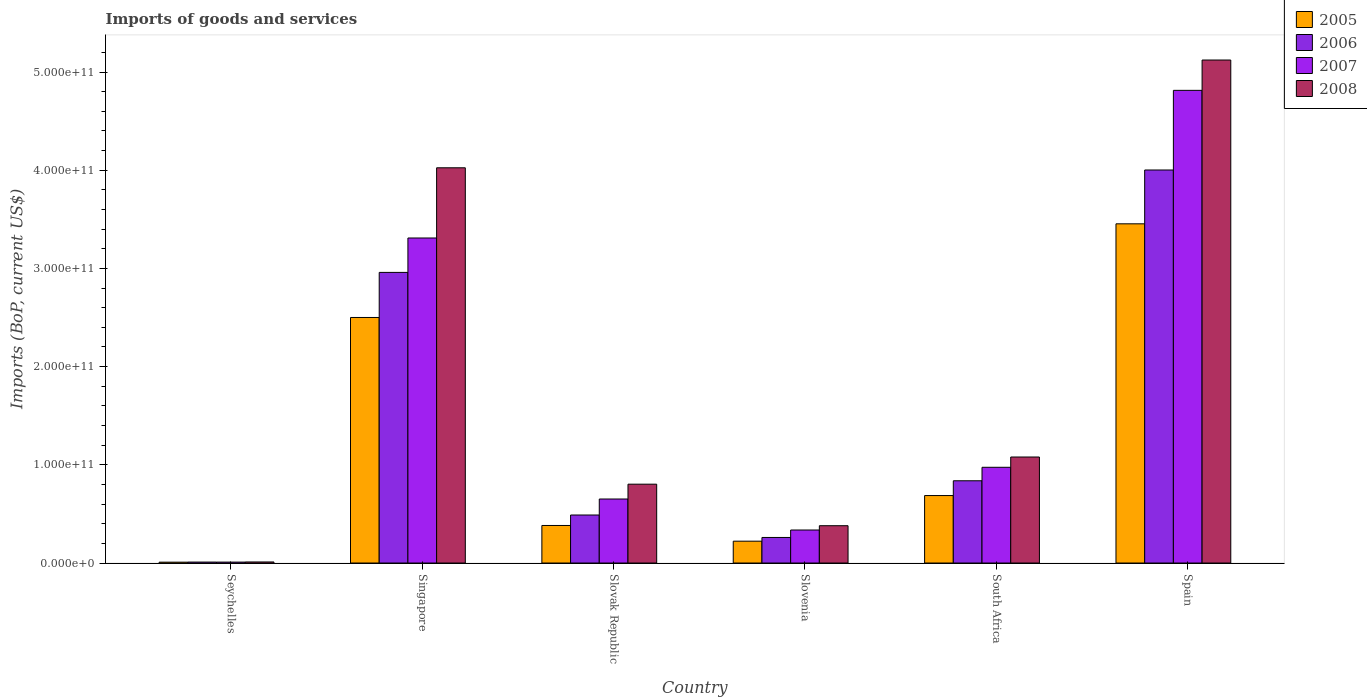How many different coloured bars are there?
Make the answer very short. 4. Are the number of bars per tick equal to the number of legend labels?
Make the answer very short. Yes. Are the number of bars on each tick of the X-axis equal?
Your response must be concise. Yes. How many bars are there on the 4th tick from the right?
Give a very brief answer. 4. What is the label of the 5th group of bars from the left?
Keep it short and to the point. South Africa. In how many cases, is the number of bars for a given country not equal to the number of legend labels?
Keep it short and to the point. 0. What is the amount spent on imports in 2008 in Slovenia?
Ensure brevity in your answer.  3.80e+1. Across all countries, what is the maximum amount spent on imports in 2006?
Ensure brevity in your answer.  4.00e+11. Across all countries, what is the minimum amount spent on imports in 2005?
Your response must be concise. 8.85e+08. In which country was the amount spent on imports in 2005 maximum?
Keep it short and to the point. Spain. In which country was the amount spent on imports in 2005 minimum?
Keep it short and to the point. Seychelles. What is the total amount spent on imports in 2007 in the graph?
Ensure brevity in your answer.  1.01e+12. What is the difference between the amount spent on imports in 2007 in Seychelles and that in Spain?
Provide a short and direct response. -4.80e+11. What is the difference between the amount spent on imports in 2007 in Seychelles and the amount spent on imports in 2005 in Slovak Republic?
Your answer should be compact. -3.73e+1. What is the average amount spent on imports in 2005 per country?
Keep it short and to the point. 1.21e+11. What is the difference between the amount spent on imports of/in 2005 and amount spent on imports of/in 2006 in Spain?
Provide a succinct answer. -5.48e+1. What is the ratio of the amount spent on imports in 2008 in Singapore to that in South Africa?
Make the answer very short. 3.73. Is the amount spent on imports in 2007 in Seychelles less than that in Slovak Republic?
Ensure brevity in your answer.  Yes. What is the difference between the highest and the second highest amount spent on imports in 2008?
Make the answer very short. 1.10e+11. What is the difference between the highest and the lowest amount spent on imports in 2008?
Your answer should be compact. 5.11e+11. In how many countries, is the amount spent on imports in 2006 greater than the average amount spent on imports in 2006 taken over all countries?
Provide a succinct answer. 2. Is the sum of the amount spent on imports in 2006 in Seychelles and Singapore greater than the maximum amount spent on imports in 2005 across all countries?
Offer a terse response. No. How many bars are there?
Provide a succinct answer. 24. Are all the bars in the graph horizontal?
Give a very brief answer. No. What is the difference between two consecutive major ticks on the Y-axis?
Your answer should be compact. 1.00e+11. Does the graph contain grids?
Provide a succinct answer. No. Where does the legend appear in the graph?
Offer a very short reply. Top right. How are the legend labels stacked?
Give a very brief answer. Vertical. What is the title of the graph?
Provide a short and direct response. Imports of goods and services. What is the label or title of the Y-axis?
Make the answer very short. Imports (BoP, current US$). What is the Imports (BoP, current US$) in 2005 in Seychelles?
Your response must be concise. 8.85e+08. What is the Imports (BoP, current US$) in 2006 in Seychelles?
Make the answer very short. 9.85e+08. What is the Imports (BoP, current US$) in 2007 in Seychelles?
Offer a terse response. 9.49e+08. What is the Imports (BoP, current US$) in 2008 in Seychelles?
Make the answer very short. 1.08e+09. What is the Imports (BoP, current US$) of 2005 in Singapore?
Provide a succinct answer. 2.50e+11. What is the Imports (BoP, current US$) of 2006 in Singapore?
Keep it short and to the point. 2.96e+11. What is the Imports (BoP, current US$) in 2007 in Singapore?
Give a very brief answer. 3.31e+11. What is the Imports (BoP, current US$) of 2008 in Singapore?
Your response must be concise. 4.03e+11. What is the Imports (BoP, current US$) in 2005 in Slovak Republic?
Provide a short and direct response. 3.82e+1. What is the Imports (BoP, current US$) in 2006 in Slovak Republic?
Your answer should be compact. 4.89e+1. What is the Imports (BoP, current US$) of 2007 in Slovak Republic?
Keep it short and to the point. 6.52e+1. What is the Imports (BoP, current US$) in 2008 in Slovak Republic?
Provide a short and direct response. 8.03e+1. What is the Imports (BoP, current US$) of 2005 in Slovenia?
Your answer should be very brief. 2.22e+1. What is the Imports (BoP, current US$) of 2006 in Slovenia?
Your answer should be compact. 2.60e+1. What is the Imports (BoP, current US$) in 2007 in Slovenia?
Give a very brief answer. 3.36e+1. What is the Imports (BoP, current US$) in 2008 in Slovenia?
Provide a succinct answer. 3.80e+1. What is the Imports (BoP, current US$) in 2005 in South Africa?
Make the answer very short. 6.87e+1. What is the Imports (BoP, current US$) in 2006 in South Africa?
Make the answer very short. 8.38e+1. What is the Imports (BoP, current US$) of 2007 in South Africa?
Provide a short and direct response. 9.75e+1. What is the Imports (BoP, current US$) of 2008 in South Africa?
Your response must be concise. 1.08e+11. What is the Imports (BoP, current US$) in 2005 in Spain?
Give a very brief answer. 3.45e+11. What is the Imports (BoP, current US$) in 2006 in Spain?
Your answer should be compact. 4.00e+11. What is the Imports (BoP, current US$) in 2007 in Spain?
Your answer should be compact. 4.81e+11. What is the Imports (BoP, current US$) of 2008 in Spain?
Provide a succinct answer. 5.12e+11. Across all countries, what is the maximum Imports (BoP, current US$) in 2005?
Offer a terse response. 3.45e+11. Across all countries, what is the maximum Imports (BoP, current US$) of 2006?
Ensure brevity in your answer.  4.00e+11. Across all countries, what is the maximum Imports (BoP, current US$) in 2007?
Keep it short and to the point. 4.81e+11. Across all countries, what is the maximum Imports (BoP, current US$) in 2008?
Provide a succinct answer. 5.12e+11. Across all countries, what is the minimum Imports (BoP, current US$) in 2005?
Offer a terse response. 8.85e+08. Across all countries, what is the minimum Imports (BoP, current US$) in 2006?
Provide a short and direct response. 9.85e+08. Across all countries, what is the minimum Imports (BoP, current US$) in 2007?
Your answer should be compact. 9.49e+08. Across all countries, what is the minimum Imports (BoP, current US$) of 2008?
Keep it short and to the point. 1.08e+09. What is the total Imports (BoP, current US$) in 2005 in the graph?
Offer a very short reply. 7.26e+11. What is the total Imports (BoP, current US$) in 2006 in the graph?
Your response must be concise. 8.56e+11. What is the total Imports (BoP, current US$) of 2007 in the graph?
Give a very brief answer. 1.01e+12. What is the total Imports (BoP, current US$) of 2008 in the graph?
Offer a terse response. 1.14e+12. What is the difference between the Imports (BoP, current US$) in 2005 in Seychelles and that in Singapore?
Offer a very short reply. -2.49e+11. What is the difference between the Imports (BoP, current US$) of 2006 in Seychelles and that in Singapore?
Provide a succinct answer. -2.95e+11. What is the difference between the Imports (BoP, current US$) of 2007 in Seychelles and that in Singapore?
Provide a short and direct response. -3.30e+11. What is the difference between the Imports (BoP, current US$) in 2008 in Seychelles and that in Singapore?
Keep it short and to the point. -4.01e+11. What is the difference between the Imports (BoP, current US$) in 2005 in Seychelles and that in Slovak Republic?
Keep it short and to the point. -3.74e+1. What is the difference between the Imports (BoP, current US$) of 2006 in Seychelles and that in Slovak Republic?
Ensure brevity in your answer.  -4.79e+1. What is the difference between the Imports (BoP, current US$) in 2007 in Seychelles and that in Slovak Republic?
Provide a succinct answer. -6.43e+1. What is the difference between the Imports (BoP, current US$) in 2008 in Seychelles and that in Slovak Republic?
Make the answer very short. -7.92e+1. What is the difference between the Imports (BoP, current US$) in 2005 in Seychelles and that in Slovenia?
Keep it short and to the point. -2.14e+1. What is the difference between the Imports (BoP, current US$) in 2006 in Seychelles and that in Slovenia?
Keep it short and to the point. -2.51e+1. What is the difference between the Imports (BoP, current US$) of 2007 in Seychelles and that in Slovenia?
Your answer should be compact. -3.27e+1. What is the difference between the Imports (BoP, current US$) of 2008 in Seychelles and that in Slovenia?
Keep it short and to the point. -3.69e+1. What is the difference between the Imports (BoP, current US$) in 2005 in Seychelles and that in South Africa?
Your answer should be very brief. -6.78e+1. What is the difference between the Imports (BoP, current US$) in 2006 in Seychelles and that in South Africa?
Your answer should be very brief. -8.28e+1. What is the difference between the Imports (BoP, current US$) in 2007 in Seychelles and that in South Africa?
Offer a terse response. -9.66e+1. What is the difference between the Imports (BoP, current US$) of 2008 in Seychelles and that in South Africa?
Offer a terse response. -1.07e+11. What is the difference between the Imports (BoP, current US$) of 2005 in Seychelles and that in Spain?
Offer a terse response. -3.45e+11. What is the difference between the Imports (BoP, current US$) in 2006 in Seychelles and that in Spain?
Your answer should be compact. -3.99e+11. What is the difference between the Imports (BoP, current US$) in 2007 in Seychelles and that in Spain?
Your answer should be very brief. -4.80e+11. What is the difference between the Imports (BoP, current US$) in 2008 in Seychelles and that in Spain?
Offer a terse response. -5.11e+11. What is the difference between the Imports (BoP, current US$) of 2005 in Singapore and that in Slovak Republic?
Provide a succinct answer. 2.12e+11. What is the difference between the Imports (BoP, current US$) of 2006 in Singapore and that in Slovak Republic?
Your answer should be compact. 2.47e+11. What is the difference between the Imports (BoP, current US$) of 2007 in Singapore and that in Slovak Republic?
Your answer should be very brief. 2.66e+11. What is the difference between the Imports (BoP, current US$) of 2008 in Singapore and that in Slovak Republic?
Your answer should be very brief. 3.22e+11. What is the difference between the Imports (BoP, current US$) of 2005 in Singapore and that in Slovenia?
Offer a very short reply. 2.28e+11. What is the difference between the Imports (BoP, current US$) in 2006 in Singapore and that in Slovenia?
Your response must be concise. 2.70e+11. What is the difference between the Imports (BoP, current US$) in 2007 in Singapore and that in Slovenia?
Provide a succinct answer. 2.97e+11. What is the difference between the Imports (BoP, current US$) in 2008 in Singapore and that in Slovenia?
Keep it short and to the point. 3.64e+11. What is the difference between the Imports (BoP, current US$) of 2005 in Singapore and that in South Africa?
Provide a short and direct response. 1.81e+11. What is the difference between the Imports (BoP, current US$) in 2006 in Singapore and that in South Africa?
Provide a short and direct response. 2.12e+11. What is the difference between the Imports (BoP, current US$) in 2007 in Singapore and that in South Africa?
Make the answer very short. 2.34e+11. What is the difference between the Imports (BoP, current US$) of 2008 in Singapore and that in South Africa?
Make the answer very short. 2.95e+11. What is the difference between the Imports (BoP, current US$) in 2005 in Singapore and that in Spain?
Your answer should be very brief. -9.54e+1. What is the difference between the Imports (BoP, current US$) of 2006 in Singapore and that in Spain?
Provide a short and direct response. -1.04e+11. What is the difference between the Imports (BoP, current US$) in 2007 in Singapore and that in Spain?
Give a very brief answer. -1.50e+11. What is the difference between the Imports (BoP, current US$) in 2008 in Singapore and that in Spain?
Your answer should be compact. -1.10e+11. What is the difference between the Imports (BoP, current US$) of 2005 in Slovak Republic and that in Slovenia?
Provide a succinct answer. 1.60e+1. What is the difference between the Imports (BoP, current US$) in 2006 in Slovak Republic and that in Slovenia?
Keep it short and to the point. 2.29e+1. What is the difference between the Imports (BoP, current US$) of 2007 in Slovak Republic and that in Slovenia?
Your answer should be compact. 3.16e+1. What is the difference between the Imports (BoP, current US$) of 2008 in Slovak Republic and that in Slovenia?
Your response must be concise. 4.23e+1. What is the difference between the Imports (BoP, current US$) of 2005 in Slovak Republic and that in South Africa?
Provide a succinct answer. -3.05e+1. What is the difference between the Imports (BoP, current US$) of 2006 in Slovak Republic and that in South Africa?
Offer a very short reply. -3.49e+1. What is the difference between the Imports (BoP, current US$) in 2007 in Slovak Republic and that in South Africa?
Provide a short and direct response. -3.23e+1. What is the difference between the Imports (BoP, current US$) of 2008 in Slovak Republic and that in South Africa?
Give a very brief answer. -2.77e+1. What is the difference between the Imports (BoP, current US$) of 2005 in Slovak Republic and that in Spain?
Keep it short and to the point. -3.07e+11. What is the difference between the Imports (BoP, current US$) in 2006 in Slovak Republic and that in Spain?
Offer a terse response. -3.51e+11. What is the difference between the Imports (BoP, current US$) of 2007 in Slovak Republic and that in Spain?
Give a very brief answer. -4.16e+11. What is the difference between the Imports (BoP, current US$) of 2008 in Slovak Republic and that in Spain?
Give a very brief answer. -4.32e+11. What is the difference between the Imports (BoP, current US$) in 2005 in Slovenia and that in South Africa?
Ensure brevity in your answer.  -4.65e+1. What is the difference between the Imports (BoP, current US$) in 2006 in Slovenia and that in South Africa?
Ensure brevity in your answer.  -5.77e+1. What is the difference between the Imports (BoP, current US$) of 2007 in Slovenia and that in South Africa?
Ensure brevity in your answer.  -6.39e+1. What is the difference between the Imports (BoP, current US$) of 2008 in Slovenia and that in South Africa?
Ensure brevity in your answer.  -7.00e+1. What is the difference between the Imports (BoP, current US$) of 2005 in Slovenia and that in Spain?
Give a very brief answer. -3.23e+11. What is the difference between the Imports (BoP, current US$) in 2006 in Slovenia and that in Spain?
Offer a very short reply. -3.74e+11. What is the difference between the Imports (BoP, current US$) in 2007 in Slovenia and that in Spain?
Ensure brevity in your answer.  -4.48e+11. What is the difference between the Imports (BoP, current US$) in 2008 in Slovenia and that in Spain?
Keep it short and to the point. -4.74e+11. What is the difference between the Imports (BoP, current US$) of 2005 in South Africa and that in Spain?
Ensure brevity in your answer.  -2.77e+11. What is the difference between the Imports (BoP, current US$) of 2006 in South Africa and that in Spain?
Your answer should be compact. -3.16e+11. What is the difference between the Imports (BoP, current US$) in 2007 in South Africa and that in Spain?
Keep it short and to the point. -3.84e+11. What is the difference between the Imports (BoP, current US$) of 2008 in South Africa and that in Spain?
Keep it short and to the point. -4.04e+11. What is the difference between the Imports (BoP, current US$) in 2005 in Seychelles and the Imports (BoP, current US$) in 2006 in Singapore?
Provide a short and direct response. -2.95e+11. What is the difference between the Imports (BoP, current US$) of 2005 in Seychelles and the Imports (BoP, current US$) of 2007 in Singapore?
Offer a very short reply. -3.30e+11. What is the difference between the Imports (BoP, current US$) in 2005 in Seychelles and the Imports (BoP, current US$) in 2008 in Singapore?
Provide a succinct answer. -4.02e+11. What is the difference between the Imports (BoP, current US$) in 2006 in Seychelles and the Imports (BoP, current US$) in 2007 in Singapore?
Ensure brevity in your answer.  -3.30e+11. What is the difference between the Imports (BoP, current US$) in 2006 in Seychelles and the Imports (BoP, current US$) in 2008 in Singapore?
Your response must be concise. -4.02e+11. What is the difference between the Imports (BoP, current US$) of 2007 in Seychelles and the Imports (BoP, current US$) of 2008 in Singapore?
Give a very brief answer. -4.02e+11. What is the difference between the Imports (BoP, current US$) in 2005 in Seychelles and the Imports (BoP, current US$) in 2006 in Slovak Republic?
Ensure brevity in your answer.  -4.80e+1. What is the difference between the Imports (BoP, current US$) of 2005 in Seychelles and the Imports (BoP, current US$) of 2007 in Slovak Republic?
Offer a terse response. -6.43e+1. What is the difference between the Imports (BoP, current US$) in 2005 in Seychelles and the Imports (BoP, current US$) in 2008 in Slovak Republic?
Ensure brevity in your answer.  -7.94e+1. What is the difference between the Imports (BoP, current US$) of 2006 in Seychelles and the Imports (BoP, current US$) of 2007 in Slovak Republic?
Provide a succinct answer. -6.42e+1. What is the difference between the Imports (BoP, current US$) of 2006 in Seychelles and the Imports (BoP, current US$) of 2008 in Slovak Republic?
Your answer should be very brief. -7.93e+1. What is the difference between the Imports (BoP, current US$) in 2007 in Seychelles and the Imports (BoP, current US$) in 2008 in Slovak Republic?
Your response must be concise. -7.93e+1. What is the difference between the Imports (BoP, current US$) in 2005 in Seychelles and the Imports (BoP, current US$) in 2006 in Slovenia?
Your answer should be compact. -2.52e+1. What is the difference between the Imports (BoP, current US$) in 2005 in Seychelles and the Imports (BoP, current US$) in 2007 in Slovenia?
Offer a terse response. -3.27e+1. What is the difference between the Imports (BoP, current US$) of 2005 in Seychelles and the Imports (BoP, current US$) of 2008 in Slovenia?
Keep it short and to the point. -3.71e+1. What is the difference between the Imports (BoP, current US$) in 2006 in Seychelles and the Imports (BoP, current US$) in 2007 in Slovenia?
Your answer should be compact. -3.26e+1. What is the difference between the Imports (BoP, current US$) of 2006 in Seychelles and the Imports (BoP, current US$) of 2008 in Slovenia?
Your response must be concise. -3.70e+1. What is the difference between the Imports (BoP, current US$) in 2007 in Seychelles and the Imports (BoP, current US$) in 2008 in Slovenia?
Your response must be concise. -3.71e+1. What is the difference between the Imports (BoP, current US$) in 2005 in Seychelles and the Imports (BoP, current US$) in 2006 in South Africa?
Your answer should be compact. -8.29e+1. What is the difference between the Imports (BoP, current US$) of 2005 in Seychelles and the Imports (BoP, current US$) of 2007 in South Africa?
Your answer should be compact. -9.66e+1. What is the difference between the Imports (BoP, current US$) in 2005 in Seychelles and the Imports (BoP, current US$) in 2008 in South Africa?
Provide a short and direct response. -1.07e+11. What is the difference between the Imports (BoP, current US$) of 2006 in Seychelles and the Imports (BoP, current US$) of 2007 in South Africa?
Offer a very short reply. -9.65e+1. What is the difference between the Imports (BoP, current US$) of 2006 in Seychelles and the Imports (BoP, current US$) of 2008 in South Africa?
Provide a succinct answer. -1.07e+11. What is the difference between the Imports (BoP, current US$) in 2007 in Seychelles and the Imports (BoP, current US$) in 2008 in South Africa?
Offer a very short reply. -1.07e+11. What is the difference between the Imports (BoP, current US$) in 2005 in Seychelles and the Imports (BoP, current US$) in 2006 in Spain?
Your answer should be compact. -3.99e+11. What is the difference between the Imports (BoP, current US$) of 2005 in Seychelles and the Imports (BoP, current US$) of 2007 in Spain?
Offer a terse response. -4.80e+11. What is the difference between the Imports (BoP, current US$) in 2005 in Seychelles and the Imports (BoP, current US$) in 2008 in Spain?
Your answer should be very brief. -5.11e+11. What is the difference between the Imports (BoP, current US$) of 2006 in Seychelles and the Imports (BoP, current US$) of 2007 in Spain?
Provide a short and direct response. -4.80e+11. What is the difference between the Imports (BoP, current US$) of 2006 in Seychelles and the Imports (BoP, current US$) of 2008 in Spain?
Ensure brevity in your answer.  -5.11e+11. What is the difference between the Imports (BoP, current US$) of 2007 in Seychelles and the Imports (BoP, current US$) of 2008 in Spain?
Your answer should be very brief. -5.11e+11. What is the difference between the Imports (BoP, current US$) of 2005 in Singapore and the Imports (BoP, current US$) of 2006 in Slovak Republic?
Keep it short and to the point. 2.01e+11. What is the difference between the Imports (BoP, current US$) of 2005 in Singapore and the Imports (BoP, current US$) of 2007 in Slovak Republic?
Offer a very short reply. 1.85e+11. What is the difference between the Imports (BoP, current US$) of 2005 in Singapore and the Imports (BoP, current US$) of 2008 in Slovak Republic?
Your answer should be compact. 1.70e+11. What is the difference between the Imports (BoP, current US$) in 2006 in Singapore and the Imports (BoP, current US$) in 2007 in Slovak Republic?
Keep it short and to the point. 2.31e+11. What is the difference between the Imports (BoP, current US$) in 2006 in Singapore and the Imports (BoP, current US$) in 2008 in Slovak Republic?
Offer a terse response. 2.16e+11. What is the difference between the Imports (BoP, current US$) in 2007 in Singapore and the Imports (BoP, current US$) in 2008 in Slovak Republic?
Keep it short and to the point. 2.51e+11. What is the difference between the Imports (BoP, current US$) in 2005 in Singapore and the Imports (BoP, current US$) in 2006 in Slovenia?
Offer a terse response. 2.24e+11. What is the difference between the Imports (BoP, current US$) of 2005 in Singapore and the Imports (BoP, current US$) of 2007 in Slovenia?
Provide a succinct answer. 2.16e+11. What is the difference between the Imports (BoP, current US$) in 2005 in Singapore and the Imports (BoP, current US$) in 2008 in Slovenia?
Provide a succinct answer. 2.12e+11. What is the difference between the Imports (BoP, current US$) in 2006 in Singapore and the Imports (BoP, current US$) in 2007 in Slovenia?
Ensure brevity in your answer.  2.62e+11. What is the difference between the Imports (BoP, current US$) of 2006 in Singapore and the Imports (BoP, current US$) of 2008 in Slovenia?
Provide a succinct answer. 2.58e+11. What is the difference between the Imports (BoP, current US$) of 2007 in Singapore and the Imports (BoP, current US$) of 2008 in Slovenia?
Provide a short and direct response. 2.93e+11. What is the difference between the Imports (BoP, current US$) in 2005 in Singapore and the Imports (BoP, current US$) in 2006 in South Africa?
Provide a succinct answer. 1.66e+11. What is the difference between the Imports (BoP, current US$) of 2005 in Singapore and the Imports (BoP, current US$) of 2007 in South Africa?
Provide a short and direct response. 1.53e+11. What is the difference between the Imports (BoP, current US$) of 2005 in Singapore and the Imports (BoP, current US$) of 2008 in South Africa?
Give a very brief answer. 1.42e+11. What is the difference between the Imports (BoP, current US$) of 2006 in Singapore and the Imports (BoP, current US$) of 2007 in South Africa?
Make the answer very short. 1.98e+11. What is the difference between the Imports (BoP, current US$) of 2006 in Singapore and the Imports (BoP, current US$) of 2008 in South Africa?
Ensure brevity in your answer.  1.88e+11. What is the difference between the Imports (BoP, current US$) of 2007 in Singapore and the Imports (BoP, current US$) of 2008 in South Africa?
Keep it short and to the point. 2.23e+11. What is the difference between the Imports (BoP, current US$) of 2005 in Singapore and the Imports (BoP, current US$) of 2006 in Spain?
Ensure brevity in your answer.  -1.50e+11. What is the difference between the Imports (BoP, current US$) of 2005 in Singapore and the Imports (BoP, current US$) of 2007 in Spain?
Keep it short and to the point. -2.31e+11. What is the difference between the Imports (BoP, current US$) in 2005 in Singapore and the Imports (BoP, current US$) in 2008 in Spain?
Give a very brief answer. -2.62e+11. What is the difference between the Imports (BoP, current US$) of 2006 in Singapore and the Imports (BoP, current US$) of 2007 in Spain?
Provide a short and direct response. -1.85e+11. What is the difference between the Imports (BoP, current US$) in 2006 in Singapore and the Imports (BoP, current US$) in 2008 in Spain?
Make the answer very short. -2.16e+11. What is the difference between the Imports (BoP, current US$) of 2007 in Singapore and the Imports (BoP, current US$) of 2008 in Spain?
Give a very brief answer. -1.81e+11. What is the difference between the Imports (BoP, current US$) in 2005 in Slovak Republic and the Imports (BoP, current US$) in 2006 in Slovenia?
Offer a terse response. 1.22e+1. What is the difference between the Imports (BoP, current US$) of 2005 in Slovak Republic and the Imports (BoP, current US$) of 2007 in Slovenia?
Your answer should be very brief. 4.62e+09. What is the difference between the Imports (BoP, current US$) of 2005 in Slovak Republic and the Imports (BoP, current US$) of 2008 in Slovenia?
Keep it short and to the point. 2.41e+08. What is the difference between the Imports (BoP, current US$) of 2006 in Slovak Republic and the Imports (BoP, current US$) of 2007 in Slovenia?
Offer a very short reply. 1.53e+1. What is the difference between the Imports (BoP, current US$) of 2006 in Slovak Republic and the Imports (BoP, current US$) of 2008 in Slovenia?
Make the answer very short. 1.09e+1. What is the difference between the Imports (BoP, current US$) of 2007 in Slovak Republic and the Imports (BoP, current US$) of 2008 in Slovenia?
Your answer should be compact. 2.72e+1. What is the difference between the Imports (BoP, current US$) in 2005 in Slovak Republic and the Imports (BoP, current US$) in 2006 in South Africa?
Offer a very short reply. -4.55e+1. What is the difference between the Imports (BoP, current US$) in 2005 in Slovak Republic and the Imports (BoP, current US$) in 2007 in South Africa?
Ensure brevity in your answer.  -5.93e+1. What is the difference between the Imports (BoP, current US$) of 2005 in Slovak Republic and the Imports (BoP, current US$) of 2008 in South Africa?
Provide a succinct answer. -6.97e+1. What is the difference between the Imports (BoP, current US$) in 2006 in Slovak Republic and the Imports (BoP, current US$) in 2007 in South Africa?
Provide a succinct answer. -4.86e+1. What is the difference between the Imports (BoP, current US$) in 2006 in Slovak Republic and the Imports (BoP, current US$) in 2008 in South Africa?
Your response must be concise. -5.91e+1. What is the difference between the Imports (BoP, current US$) of 2007 in Slovak Republic and the Imports (BoP, current US$) of 2008 in South Africa?
Your answer should be compact. -4.28e+1. What is the difference between the Imports (BoP, current US$) in 2005 in Slovak Republic and the Imports (BoP, current US$) in 2006 in Spain?
Offer a terse response. -3.62e+11. What is the difference between the Imports (BoP, current US$) of 2005 in Slovak Republic and the Imports (BoP, current US$) of 2007 in Spain?
Make the answer very short. -4.43e+11. What is the difference between the Imports (BoP, current US$) in 2005 in Slovak Republic and the Imports (BoP, current US$) in 2008 in Spain?
Provide a succinct answer. -4.74e+11. What is the difference between the Imports (BoP, current US$) of 2006 in Slovak Republic and the Imports (BoP, current US$) of 2007 in Spain?
Offer a terse response. -4.32e+11. What is the difference between the Imports (BoP, current US$) in 2006 in Slovak Republic and the Imports (BoP, current US$) in 2008 in Spain?
Offer a terse response. -4.63e+11. What is the difference between the Imports (BoP, current US$) in 2007 in Slovak Republic and the Imports (BoP, current US$) in 2008 in Spain?
Give a very brief answer. -4.47e+11. What is the difference between the Imports (BoP, current US$) in 2005 in Slovenia and the Imports (BoP, current US$) in 2006 in South Africa?
Provide a succinct answer. -6.15e+1. What is the difference between the Imports (BoP, current US$) in 2005 in Slovenia and the Imports (BoP, current US$) in 2007 in South Africa?
Offer a very short reply. -7.53e+1. What is the difference between the Imports (BoP, current US$) in 2005 in Slovenia and the Imports (BoP, current US$) in 2008 in South Africa?
Make the answer very short. -8.57e+1. What is the difference between the Imports (BoP, current US$) of 2006 in Slovenia and the Imports (BoP, current US$) of 2007 in South Africa?
Your answer should be very brief. -7.15e+1. What is the difference between the Imports (BoP, current US$) in 2006 in Slovenia and the Imports (BoP, current US$) in 2008 in South Africa?
Your answer should be compact. -8.19e+1. What is the difference between the Imports (BoP, current US$) in 2007 in Slovenia and the Imports (BoP, current US$) in 2008 in South Africa?
Give a very brief answer. -7.43e+1. What is the difference between the Imports (BoP, current US$) in 2005 in Slovenia and the Imports (BoP, current US$) in 2006 in Spain?
Make the answer very short. -3.78e+11. What is the difference between the Imports (BoP, current US$) of 2005 in Slovenia and the Imports (BoP, current US$) of 2007 in Spain?
Your answer should be very brief. -4.59e+11. What is the difference between the Imports (BoP, current US$) of 2005 in Slovenia and the Imports (BoP, current US$) of 2008 in Spain?
Provide a short and direct response. -4.90e+11. What is the difference between the Imports (BoP, current US$) in 2006 in Slovenia and the Imports (BoP, current US$) in 2007 in Spain?
Keep it short and to the point. -4.55e+11. What is the difference between the Imports (BoP, current US$) in 2006 in Slovenia and the Imports (BoP, current US$) in 2008 in Spain?
Provide a short and direct response. -4.86e+11. What is the difference between the Imports (BoP, current US$) of 2007 in Slovenia and the Imports (BoP, current US$) of 2008 in Spain?
Make the answer very short. -4.79e+11. What is the difference between the Imports (BoP, current US$) of 2005 in South Africa and the Imports (BoP, current US$) of 2006 in Spain?
Your answer should be very brief. -3.32e+11. What is the difference between the Imports (BoP, current US$) in 2005 in South Africa and the Imports (BoP, current US$) in 2007 in Spain?
Keep it short and to the point. -4.13e+11. What is the difference between the Imports (BoP, current US$) of 2005 in South Africa and the Imports (BoP, current US$) of 2008 in Spain?
Make the answer very short. -4.44e+11. What is the difference between the Imports (BoP, current US$) of 2006 in South Africa and the Imports (BoP, current US$) of 2007 in Spain?
Provide a short and direct response. -3.98e+11. What is the difference between the Imports (BoP, current US$) of 2006 in South Africa and the Imports (BoP, current US$) of 2008 in Spain?
Give a very brief answer. -4.28e+11. What is the difference between the Imports (BoP, current US$) of 2007 in South Africa and the Imports (BoP, current US$) of 2008 in Spain?
Ensure brevity in your answer.  -4.15e+11. What is the average Imports (BoP, current US$) of 2005 per country?
Provide a short and direct response. 1.21e+11. What is the average Imports (BoP, current US$) in 2006 per country?
Offer a very short reply. 1.43e+11. What is the average Imports (BoP, current US$) of 2007 per country?
Your answer should be compact. 1.68e+11. What is the average Imports (BoP, current US$) in 2008 per country?
Offer a very short reply. 1.90e+11. What is the difference between the Imports (BoP, current US$) in 2005 and Imports (BoP, current US$) in 2006 in Seychelles?
Make the answer very short. -9.96e+07. What is the difference between the Imports (BoP, current US$) in 2005 and Imports (BoP, current US$) in 2007 in Seychelles?
Keep it short and to the point. -6.38e+07. What is the difference between the Imports (BoP, current US$) of 2005 and Imports (BoP, current US$) of 2008 in Seychelles?
Ensure brevity in your answer.  -1.99e+08. What is the difference between the Imports (BoP, current US$) of 2006 and Imports (BoP, current US$) of 2007 in Seychelles?
Your response must be concise. 3.58e+07. What is the difference between the Imports (BoP, current US$) in 2006 and Imports (BoP, current US$) in 2008 in Seychelles?
Provide a short and direct response. -9.99e+07. What is the difference between the Imports (BoP, current US$) in 2007 and Imports (BoP, current US$) in 2008 in Seychelles?
Offer a terse response. -1.36e+08. What is the difference between the Imports (BoP, current US$) of 2005 and Imports (BoP, current US$) of 2006 in Singapore?
Offer a very short reply. -4.59e+1. What is the difference between the Imports (BoP, current US$) in 2005 and Imports (BoP, current US$) in 2007 in Singapore?
Make the answer very short. -8.10e+1. What is the difference between the Imports (BoP, current US$) of 2005 and Imports (BoP, current US$) of 2008 in Singapore?
Provide a succinct answer. -1.52e+11. What is the difference between the Imports (BoP, current US$) in 2006 and Imports (BoP, current US$) in 2007 in Singapore?
Your answer should be very brief. -3.50e+1. What is the difference between the Imports (BoP, current US$) of 2006 and Imports (BoP, current US$) of 2008 in Singapore?
Keep it short and to the point. -1.07e+11. What is the difference between the Imports (BoP, current US$) in 2007 and Imports (BoP, current US$) in 2008 in Singapore?
Keep it short and to the point. -7.15e+1. What is the difference between the Imports (BoP, current US$) in 2005 and Imports (BoP, current US$) in 2006 in Slovak Republic?
Provide a short and direct response. -1.07e+1. What is the difference between the Imports (BoP, current US$) of 2005 and Imports (BoP, current US$) of 2007 in Slovak Republic?
Provide a short and direct response. -2.70e+1. What is the difference between the Imports (BoP, current US$) in 2005 and Imports (BoP, current US$) in 2008 in Slovak Republic?
Offer a terse response. -4.20e+1. What is the difference between the Imports (BoP, current US$) in 2006 and Imports (BoP, current US$) in 2007 in Slovak Republic?
Your answer should be very brief. -1.63e+1. What is the difference between the Imports (BoP, current US$) in 2006 and Imports (BoP, current US$) in 2008 in Slovak Republic?
Provide a short and direct response. -3.14e+1. What is the difference between the Imports (BoP, current US$) in 2007 and Imports (BoP, current US$) in 2008 in Slovak Republic?
Your answer should be very brief. -1.51e+1. What is the difference between the Imports (BoP, current US$) in 2005 and Imports (BoP, current US$) in 2006 in Slovenia?
Provide a succinct answer. -3.79e+09. What is the difference between the Imports (BoP, current US$) of 2005 and Imports (BoP, current US$) of 2007 in Slovenia?
Your response must be concise. -1.14e+1. What is the difference between the Imports (BoP, current US$) of 2005 and Imports (BoP, current US$) of 2008 in Slovenia?
Provide a succinct answer. -1.58e+1. What is the difference between the Imports (BoP, current US$) in 2006 and Imports (BoP, current US$) in 2007 in Slovenia?
Keep it short and to the point. -7.59e+09. What is the difference between the Imports (BoP, current US$) in 2006 and Imports (BoP, current US$) in 2008 in Slovenia?
Keep it short and to the point. -1.20e+1. What is the difference between the Imports (BoP, current US$) in 2007 and Imports (BoP, current US$) in 2008 in Slovenia?
Your answer should be very brief. -4.38e+09. What is the difference between the Imports (BoP, current US$) in 2005 and Imports (BoP, current US$) in 2006 in South Africa?
Offer a terse response. -1.50e+1. What is the difference between the Imports (BoP, current US$) of 2005 and Imports (BoP, current US$) of 2007 in South Africa?
Your answer should be very brief. -2.88e+1. What is the difference between the Imports (BoP, current US$) of 2005 and Imports (BoP, current US$) of 2008 in South Africa?
Make the answer very short. -3.93e+1. What is the difference between the Imports (BoP, current US$) in 2006 and Imports (BoP, current US$) in 2007 in South Africa?
Provide a short and direct response. -1.37e+1. What is the difference between the Imports (BoP, current US$) in 2006 and Imports (BoP, current US$) in 2008 in South Africa?
Ensure brevity in your answer.  -2.42e+1. What is the difference between the Imports (BoP, current US$) in 2007 and Imports (BoP, current US$) in 2008 in South Africa?
Your answer should be very brief. -1.05e+1. What is the difference between the Imports (BoP, current US$) in 2005 and Imports (BoP, current US$) in 2006 in Spain?
Your answer should be compact. -5.48e+1. What is the difference between the Imports (BoP, current US$) in 2005 and Imports (BoP, current US$) in 2007 in Spain?
Your response must be concise. -1.36e+11. What is the difference between the Imports (BoP, current US$) of 2005 and Imports (BoP, current US$) of 2008 in Spain?
Your answer should be very brief. -1.67e+11. What is the difference between the Imports (BoP, current US$) in 2006 and Imports (BoP, current US$) in 2007 in Spain?
Provide a short and direct response. -8.11e+1. What is the difference between the Imports (BoP, current US$) of 2006 and Imports (BoP, current US$) of 2008 in Spain?
Provide a succinct answer. -1.12e+11. What is the difference between the Imports (BoP, current US$) in 2007 and Imports (BoP, current US$) in 2008 in Spain?
Ensure brevity in your answer.  -3.09e+1. What is the ratio of the Imports (BoP, current US$) in 2005 in Seychelles to that in Singapore?
Your response must be concise. 0. What is the ratio of the Imports (BoP, current US$) in 2006 in Seychelles to that in Singapore?
Give a very brief answer. 0. What is the ratio of the Imports (BoP, current US$) of 2007 in Seychelles to that in Singapore?
Your answer should be compact. 0. What is the ratio of the Imports (BoP, current US$) in 2008 in Seychelles to that in Singapore?
Ensure brevity in your answer.  0. What is the ratio of the Imports (BoP, current US$) in 2005 in Seychelles to that in Slovak Republic?
Your answer should be very brief. 0.02. What is the ratio of the Imports (BoP, current US$) of 2006 in Seychelles to that in Slovak Republic?
Offer a very short reply. 0.02. What is the ratio of the Imports (BoP, current US$) in 2007 in Seychelles to that in Slovak Republic?
Give a very brief answer. 0.01. What is the ratio of the Imports (BoP, current US$) of 2008 in Seychelles to that in Slovak Republic?
Offer a terse response. 0.01. What is the ratio of the Imports (BoP, current US$) of 2005 in Seychelles to that in Slovenia?
Offer a very short reply. 0.04. What is the ratio of the Imports (BoP, current US$) in 2006 in Seychelles to that in Slovenia?
Offer a terse response. 0.04. What is the ratio of the Imports (BoP, current US$) of 2007 in Seychelles to that in Slovenia?
Your answer should be compact. 0.03. What is the ratio of the Imports (BoP, current US$) of 2008 in Seychelles to that in Slovenia?
Provide a short and direct response. 0.03. What is the ratio of the Imports (BoP, current US$) of 2005 in Seychelles to that in South Africa?
Your answer should be compact. 0.01. What is the ratio of the Imports (BoP, current US$) of 2006 in Seychelles to that in South Africa?
Make the answer very short. 0.01. What is the ratio of the Imports (BoP, current US$) of 2007 in Seychelles to that in South Africa?
Give a very brief answer. 0.01. What is the ratio of the Imports (BoP, current US$) in 2008 in Seychelles to that in South Africa?
Ensure brevity in your answer.  0.01. What is the ratio of the Imports (BoP, current US$) in 2005 in Seychelles to that in Spain?
Give a very brief answer. 0. What is the ratio of the Imports (BoP, current US$) of 2006 in Seychelles to that in Spain?
Ensure brevity in your answer.  0. What is the ratio of the Imports (BoP, current US$) of 2007 in Seychelles to that in Spain?
Keep it short and to the point. 0. What is the ratio of the Imports (BoP, current US$) of 2008 in Seychelles to that in Spain?
Give a very brief answer. 0. What is the ratio of the Imports (BoP, current US$) of 2005 in Singapore to that in Slovak Republic?
Your answer should be compact. 6.54. What is the ratio of the Imports (BoP, current US$) in 2006 in Singapore to that in Slovak Republic?
Your answer should be compact. 6.05. What is the ratio of the Imports (BoP, current US$) of 2007 in Singapore to that in Slovak Republic?
Offer a very short reply. 5.08. What is the ratio of the Imports (BoP, current US$) in 2008 in Singapore to that in Slovak Republic?
Your answer should be very brief. 5.01. What is the ratio of the Imports (BoP, current US$) in 2005 in Singapore to that in Slovenia?
Ensure brevity in your answer.  11.24. What is the ratio of the Imports (BoP, current US$) of 2006 in Singapore to that in Slovenia?
Ensure brevity in your answer.  11.37. What is the ratio of the Imports (BoP, current US$) of 2007 in Singapore to that in Slovenia?
Provide a succinct answer. 9.84. What is the ratio of the Imports (BoP, current US$) in 2008 in Singapore to that in Slovenia?
Keep it short and to the point. 10.59. What is the ratio of the Imports (BoP, current US$) of 2005 in Singapore to that in South Africa?
Make the answer very short. 3.64. What is the ratio of the Imports (BoP, current US$) in 2006 in Singapore to that in South Africa?
Offer a very short reply. 3.53. What is the ratio of the Imports (BoP, current US$) in 2007 in Singapore to that in South Africa?
Your answer should be very brief. 3.39. What is the ratio of the Imports (BoP, current US$) of 2008 in Singapore to that in South Africa?
Provide a succinct answer. 3.73. What is the ratio of the Imports (BoP, current US$) of 2005 in Singapore to that in Spain?
Your response must be concise. 0.72. What is the ratio of the Imports (BoP, current US$) of 2006 in Singapore to that in Spain?
Offer a terse response. 0.74. What is the ratio of the Imports (BoP, current US$) of 2007 in Singapore to that in Spain?
Offer a very short reply. 0.69. What is the ratio of the Imports (BoP, current US$) of 2008 in Singapore to that in Spain?
Offer a terse response. 0.79. What is the ratio of the Imports (BoP, current US$) of 2005 in Slovak Republic to that in Slovenia?
Offer a terse response. 1.72. What is the ratio of the Imports (BoP, current US$) in 2006 in Slovak Republic to that in Slovenia?
Give a very brief answer. 1.88. What is the ratio of the Imports (BoP, current US$) in 2007 in Slovak Republic to that in Slovenia?
Make the answer very short. 1.94. What is the ratio of the Imports (BoP, current US$) in 2008 in Slovak Republic to that in Slovenia?
Provide a succinct answer. 2.11. What is the ratio of the Imports (BoP, current US$) in 2005 in Slovak Republic to that in South Africa?
Provide a short and direct response. 0.56. What is the ratio of the Imports (BoP, current US$) in 2006 in Slovak Republic to that in South Africa?
Provide a succinct answer. 0.58. What is the ratio of the Imports (BoP, current US$) of 2007 in Slovak Republic to that in South Africa?
Make the answer very short. 0.67. What is the ratio of the Imports (BoP, current US$) in 2008 in Slovak Republic to that in South Africa?
Provide a short and direct response. 0.74. What is the ratio of the Imports (BoP, current US$) of 2005 in Slovak Republic to that in Spain?
Provide a short and direct response. 0.11. What is the ratio of the Imports (BoP, current US$) in 2006 in Slovak Republic to that in Spain?
Your answer should be compact. 0.12. What is the ratio of the Imports (BoP, current US$) of 2007 in Slovak Republic to that in Spain?
Your answer should be very brief. 0.14. What is the ratio of the Imports (BoP, current US$) in 2008 in Slovak Republic to that in Spain?
Your response must be concise. 0.16. What is the ratio of the Imports (BoP, current US$) in 2005 in Slovenia to that in South Africa?
Keep it short and to the point. 0.32. What is the ratio of the Imports (BoP, current US$) of 2006 in Slovenia to that in South Africa?
Your answer should be compact. 0.31. What is the ratio of the Imports (BoP, current US$) of 2007 in Slovenia to that in South Africa?
Offer a terse response. 0.34. What is the ratio of the Imports (BoP, current US$) of 2008 in Slovenia to that in South Africa?
Ensure brevity in your answer.  0.35. What is the ratio of the Imports (BoP, current US$) of 2005 in Slovenia to that in Spain?
Your response must be concise. 0.06. What is the ratio of the Imports (BoP, current US$) in 2006 in Slovenia to that in Spain?
Your answer should be compact. 0.07. What is the ratio of the Imports (BoP, current US$) in 2007 in Slovenia to that in Spain?
Your answer should be compact. 0.07. What is the ratio of the Imports (BoP, current US$) of 2008 in Slovenia to that in Spain?
Offer a very short reply. 0.07. What is the ratio of the Imports (BoP, current US$) in 2005 in South Africa to that in Spain?
Your response must be concise. 0.2. What is the ratio of the Imports (BoP, current US$) of 2006 in South Africa to that in Spain?
Offer a very short reply. 0.21. What is the ratio of the Imports (BoP, current US$) in 2007 in South Africa to that in Spain?
Your answer should be compact. 0.2. What is the ratio of the Imports (BoP, current US$) of 2008 in South Africa to that in Spain?
Provide a succinct answer. 0.21. What is the difference between the highest and the second highest Imports (BoP, current US$) in 2005?
Provide a short and direct response. 9.54e+1. What is the difference between the highest and the second highest Imports (BoP, current US$) in 2006?
Give a very brief answer. 1.04e+11. What is the difference between the highest and the second highest Imports (BoP, current US$) of 2007?
Keep it short and to the point. 1.50e+11. What is the difference between the highest and the second highest Imports (BoP, current US$) of 2008?
Give a very brief answer. 1.10e+11. What is the difference between the highest and the lowest Imports (BoP, current US$) of 2005?
Ensure brevity in your answer.  3.45e+11. What is the difference between the highest and the lowest Imports (BoP, current US$) in 2006?
Make the answer very short. 3.99e+11. What is the difference between the highest and the lowest Imports (BoP, current US$) of 2007?
Make the answer very short. 4.80e+11. What is the difference between the highest and the lowest Imports (BoP, current US$) of 2008?
Offer a very short reply. 5.11e+11. 